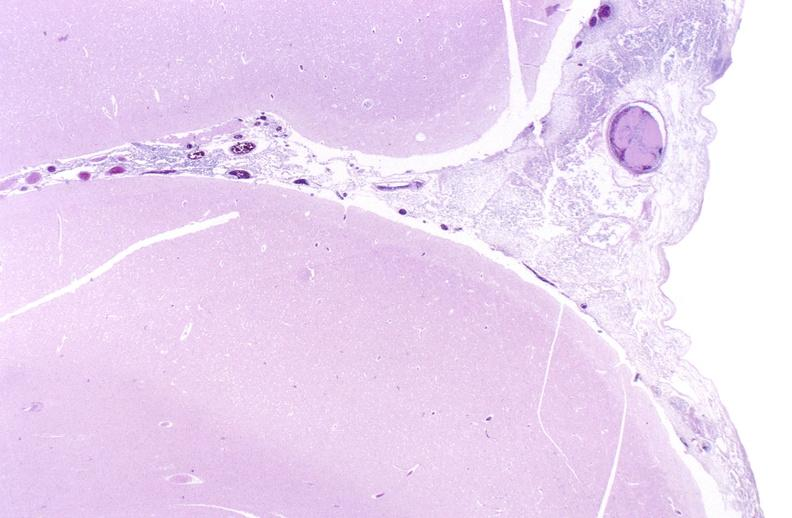s epididymis present?
Answer the question using a single word or phrase. No 